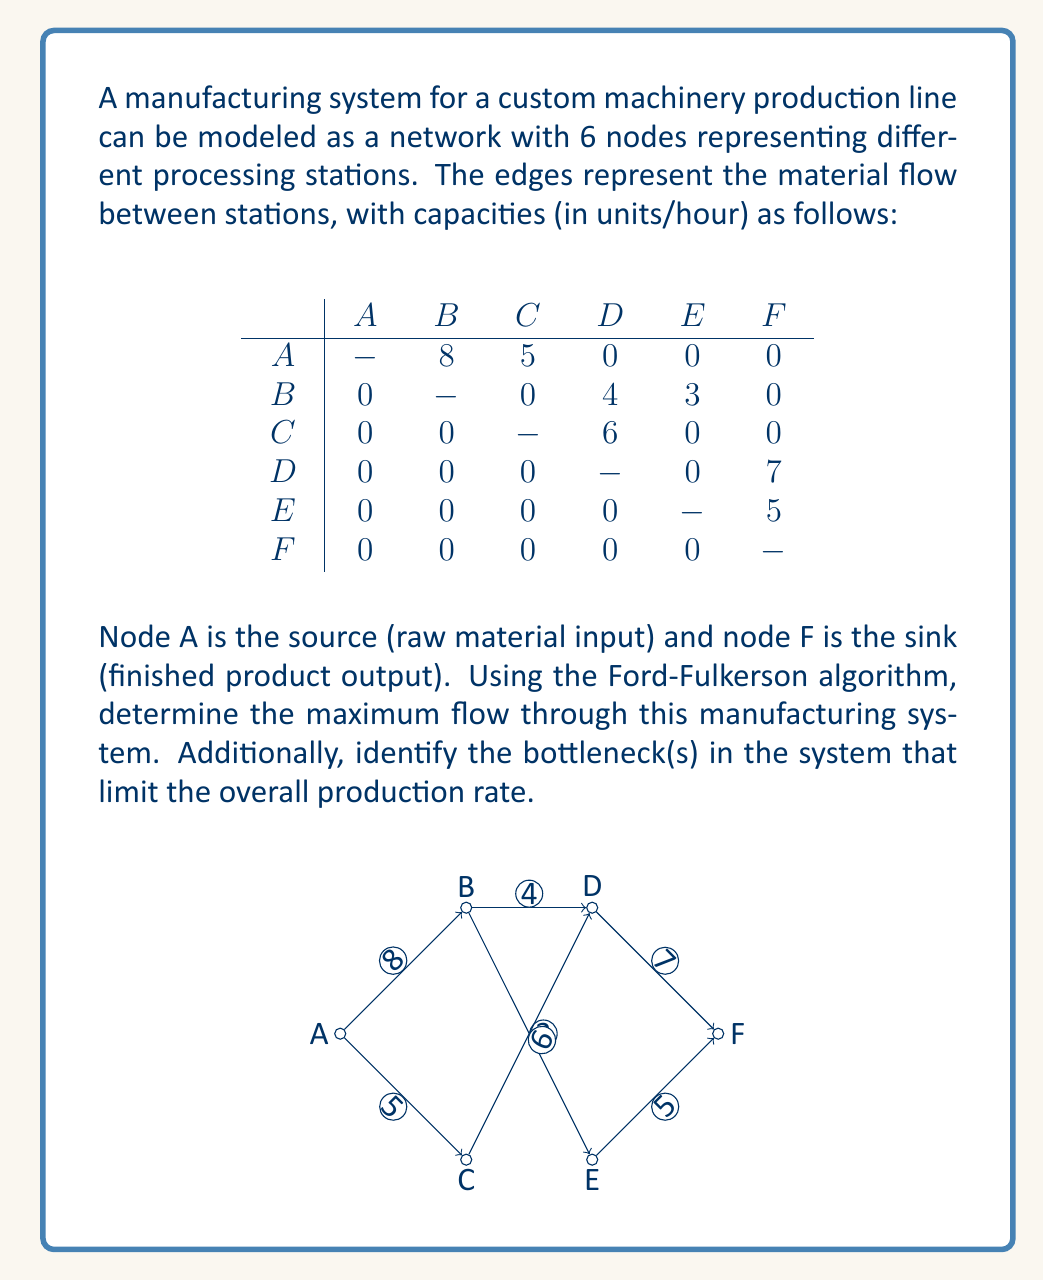Provide a solution to this math problem. To solve this problem, we'll apply the Ford-Fulkerson algorithm to find the maximum flow in the network. The algorithm works as follows:

1. Initialize all flows to 0.
2. Find an augmenting path from source to sink.
3. Determine the bottleneck capacity of the path.
4. Update the flows along the path.
5. Repeat steps 2-4 until no augmenting path exists.

Let's apply the algorithm step by step:

Iteration 1:
Path: A -> B -> D -> F
Bottleneck: min(8, 4, 7) = 4
Flow: 4

Iteration 2:
Path: A -> C -> D -> F
Bottleneck: min(5, 6, 3) = 3
Flow: 4 + 3 = 7

Iteration 3:
Path: A -> B -> E -> F
Bottleneck: min(4, 3, 5) = 3
Flow: 7 + 3 = 10

No more augmenting paths exist, so the maximum flow is 10 units/hour.

To identify the bottlenecks, we need to find the minimum cut in the network. The minimum cut separates the nodes into two sets: those reachable from the source in the residual graph, and those that are not.

Reachable nodes: A, B, C
Unreachable nodes: D, E, F

The edges crossing this cut are:
B -> D (capacity 4, fully utilized)
C -> D (capacity 6, partially utilized)
B -> E (capacity 3, fully utilized)

The bottlenecks are the edges B -> D and B -> E, as they are fully utilized and limit the overall flow.
Answer: The maximum flow through the manufacturing system is 10 units/hour. The bottlenecks in the system are the edges from B to D (capacity 4 units/hour) and from B to E (capacity 3 units/hour), which limit the overall production rate. 